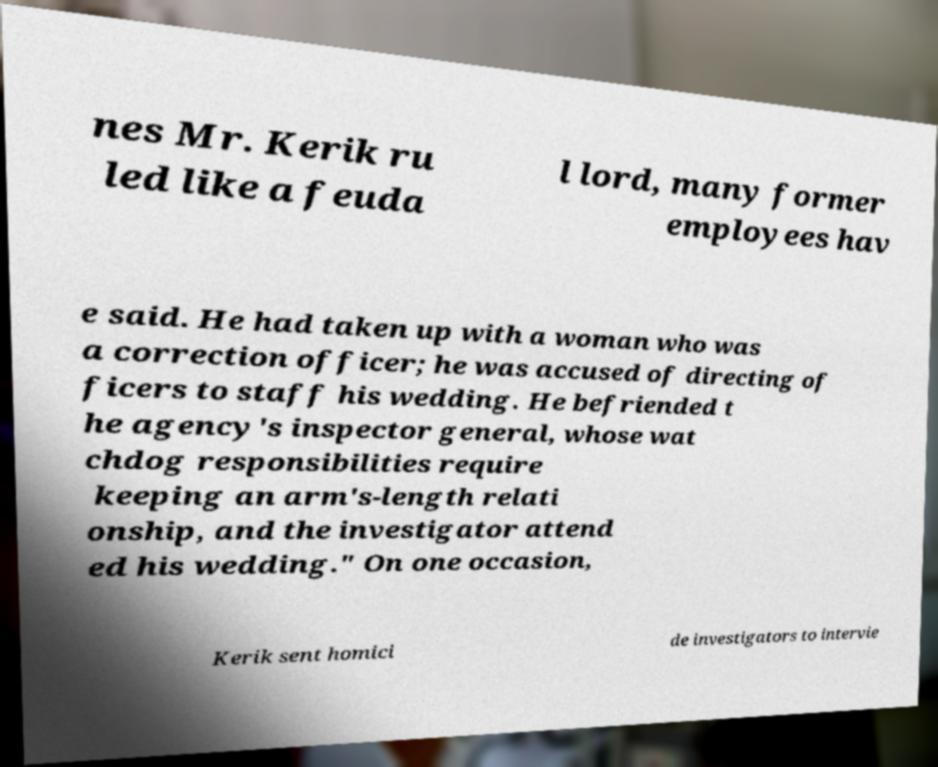Can you accurately transcribe the text from the provided image for me? nes Mr. Kerik ru led like a feuda l lord, many former employees hav e said. He had taken up with a woman who was a correction officer; he was accused of directing of ficers to staff his wedding. He befriended t he agency's inspector general, whose wat chdog responsibilities require keeping an arm's-length relati onship, and the investigator attend ed his wedding." On one occasion, Kerik sent homici de investigators to intervie 